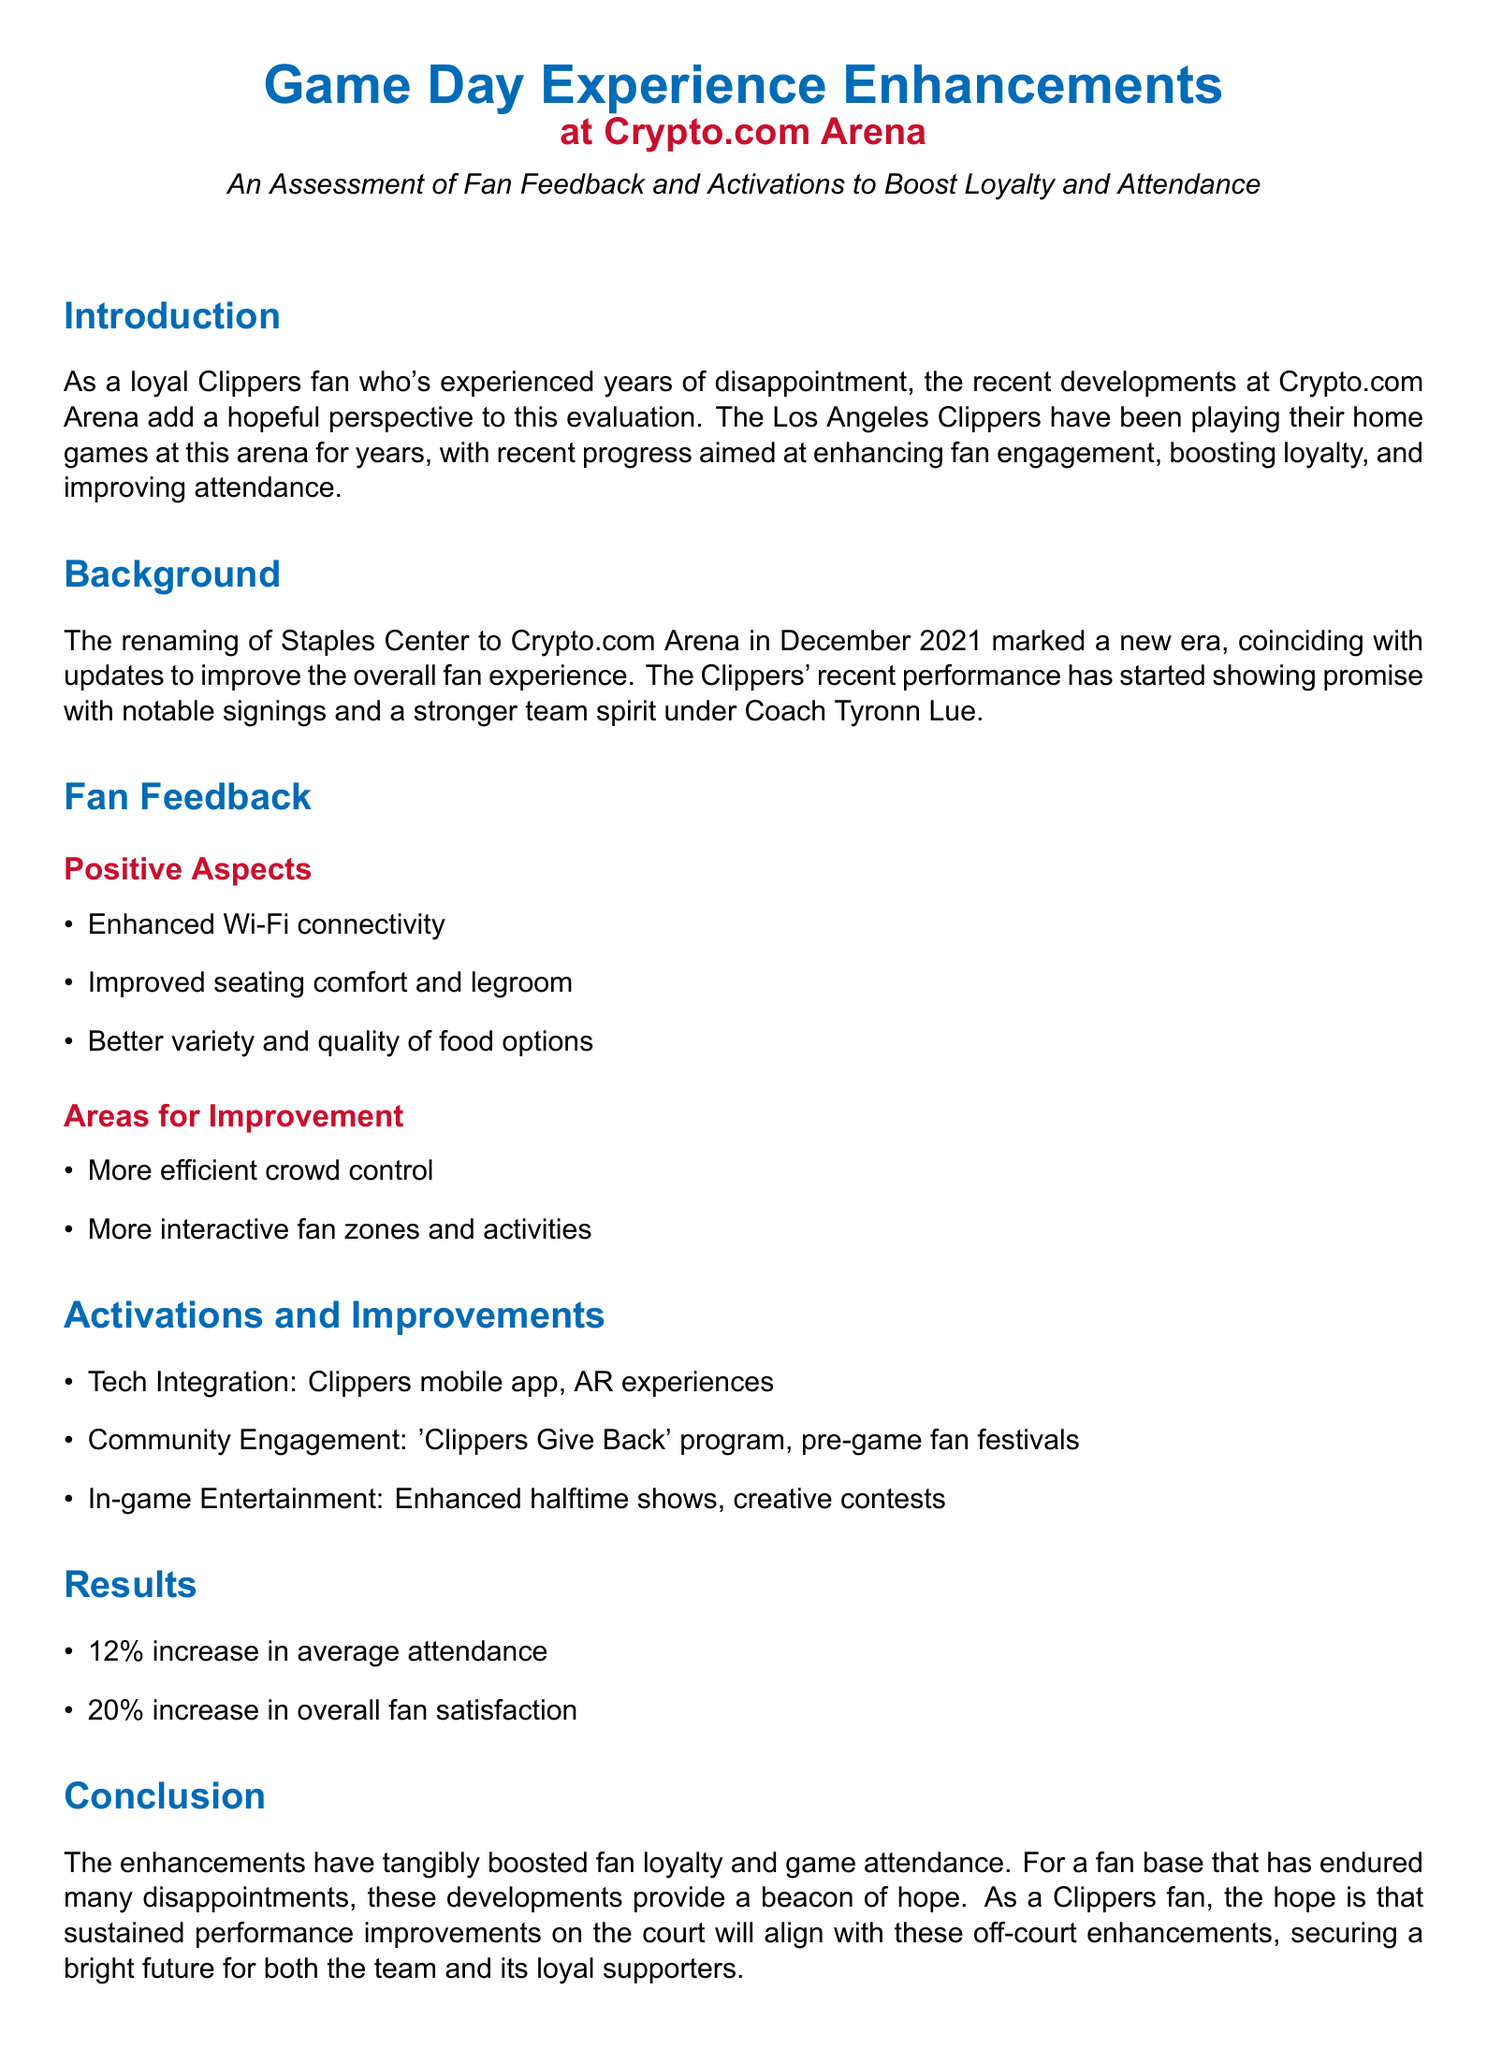what is the name of the arena? The arena was renamed from Staples Center to Crypto.com Arena in December 2021.
Answer: Crypto.com Arena what was the percentage increase in average attendance? The document states that there was a 12% increase in average attendance after the enhancements.
Answer: 12% what percentage increase in overall fan satisfaction was reported? There was a 20% increase in overall fan satisfaction noted in the document.
Answer: 20% what enhancements were made to food options? The document mentions improved variety and quality of food options as a positive aspect of the fan experience.
Answer: Variety and quality what is one area identified for improvement regarding crowd management? The document lists more efficient crowd control as a necessary area for improvement.
Answer: Crowd control what is one of the tech integrations mentioned? The Clippers mobile app is mentioned as part of the tech integration efforts to enhance fan experience.
Answer: Clippers mobile app what program is mentioned for community engagement? The 'Clippers Give Back' program is highlighted in the document as an initiative for community engagement.
Answer: Clippers Give Back what is the key theme of the conclusion section? The conclusion emphasizes the hope for sustained performance improvements aligning with off-court enhancements.
Answer: Hope what in-game entertainment improvement is noted? Enhanced halftime shows are mentioned as part of the in-game entertainment improvements.
Answer: Enhanced halftime shows 